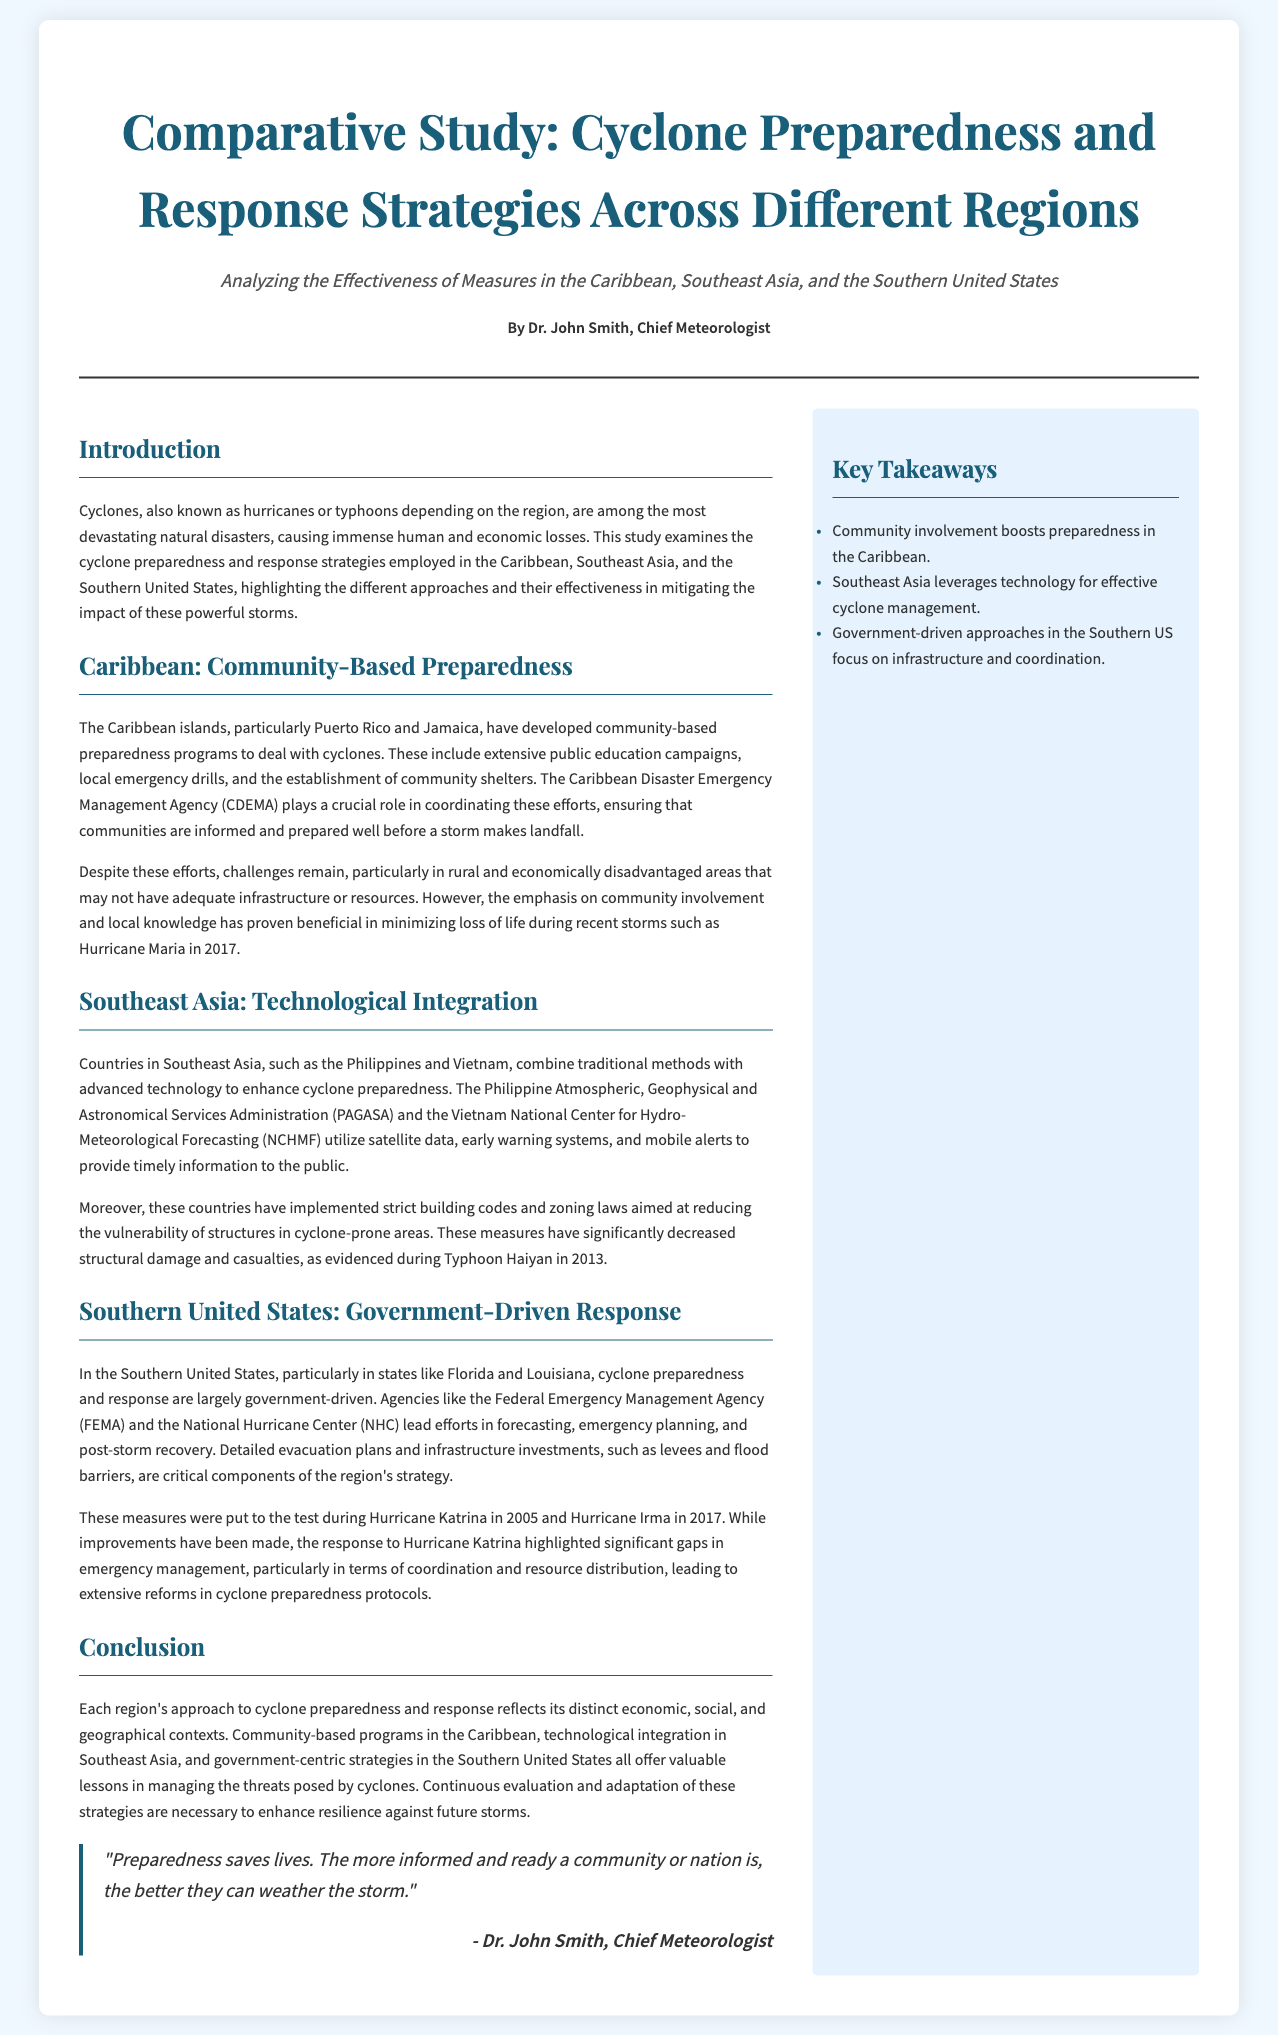What are the three regions analyzed in the study? The document discusses cyclone preparedness in the Caribbean, Southeast Asia, and the Southern United States.
Answer: Caribbean, Southeast Asia, Southern United States Who is the author of the article? The byline mentions Dr. John Smith as the Chief Meteorologist who authored the piece.
Answer: Dr. John Smith What role does CDEMA play in the Caribbean? The Caribbean Disaster Emergency Management Agency (CDEMA) coordinates community-based preparedness efforts.
Answer: Coordinates community-based preparedness What technological resources are used in Southeast Asia for cyclone preparedness? Southeast Asia uses satellite data, early warning systems, and mobile alerts to provide timely information.
Answer: Satellite data, early warning systems, mobile alerts Which hurricane highlighted significant gaps in emergency management in the Southern United States? Hurricane Katrina in 2005 exposed weaknesses in emergency planning, coordination, and resource distribution.
Answer: Hurricane Katrina What type of preparedness programs are effective in the Caribbean? Community-based preparedness programs, including public education campaigns and local emergency drills, are significant.
Answer: Community-based preparedness programs What was a key lesson learned from the response to Hurricane Irma in the Southern United States? The document suggests that improvements were made in response strategies following the lessons learned from previous storms.
Answer: Improvements made in response strategies What kind of measures minimize structural damage in Southeast Asia? Strict building codes and zoning laws have been implemented to reduce vulnerability in cyclone-prone areas.
Answer: Strict building codes and zoning laws 